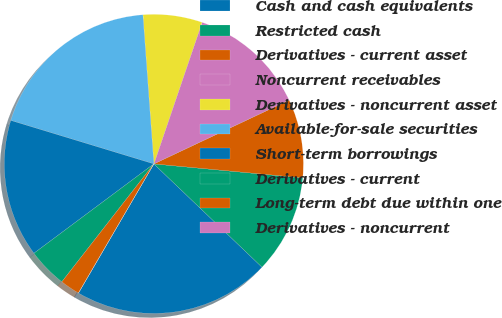Convert chart. <chart><loc_0><loc_0><loc_500><loc_500><pie_chart><fcel>Cash and cash equivalents<fcel>Restricted cash<fcel>Derivatives - current asset<fcel>Noncurrent receivables<fcel>Derivatives - noncurrent asset<fcel>Available-for-sale securities<fcel>Short-term borrowings<fcel>Derivatives - current<fcel>Long-term debt due within one<fcel>Derivatives - noncurrent<nl><fcel>21.27%<fcel>10.64%<fcel>8.51%<fcel>12.76%<fcel>6.39%<fcel>19.14%<fcel>14.89%<fcel>4.26%<fcel>2.13%<fcel>0.01%<nl></chart> 